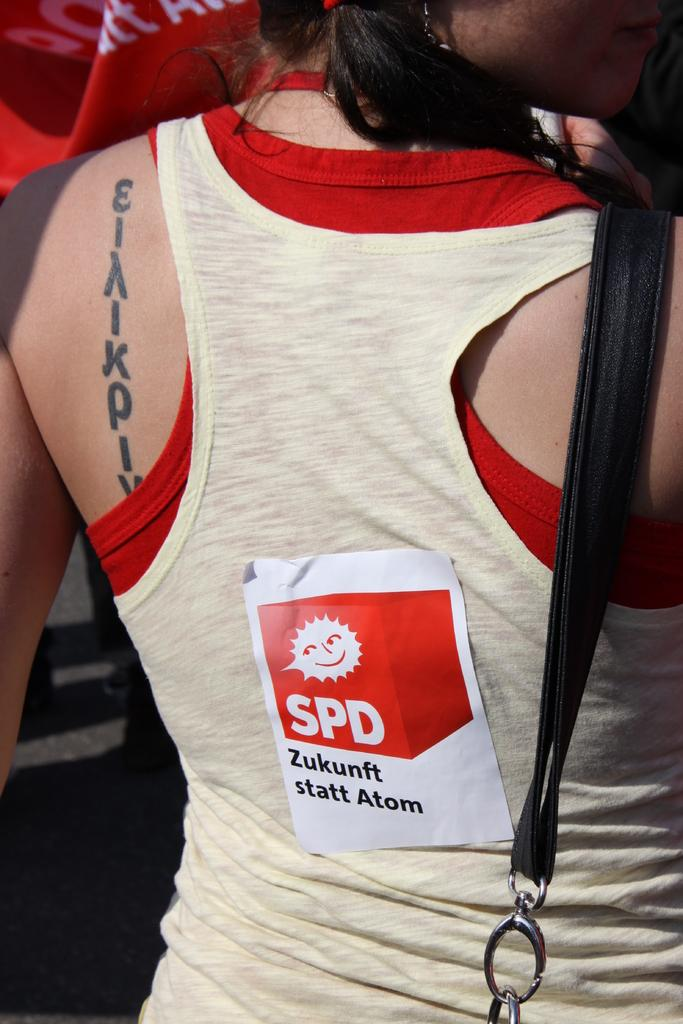Provide a one-sentence caption for the provided image. A woman with a tattoo has a sticker on her back that says SPD. 